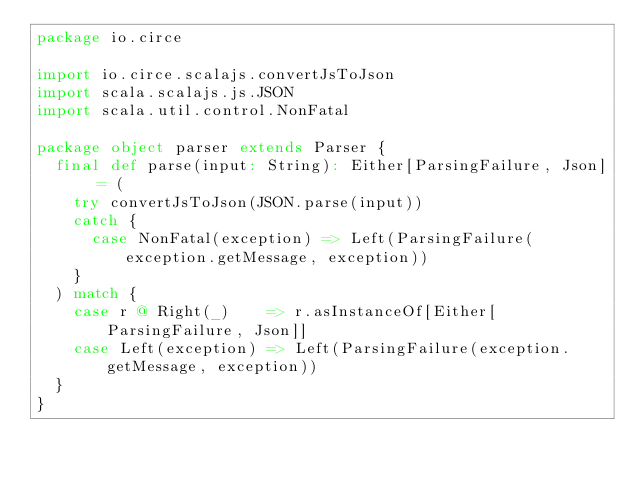<code> <loc_0><loc_0><loc_500><loc_500><_Scala_>package io.circe

import io.circe.scalajs.convertJsToJson
import scala.scalajs.js.JSON
import scala.util.control.NonFatal

package object parser extends Parser {
  final def parse(input: String): Either[ParsingFailure, Json] = (
    try convertJsToJson(JSON.parse(input))
    catch {
      case NonFatal(exception) => Left(ParsingFailure(exception.getMessage, exception))
    }
  ) match {
    case r @ Right(_)    => r.asInstanceOf[Either[ParsingFailure, Json]]
    case Left(exception) => Left(ParsingFailure(exception.getMessage, exception))
  }
}
</code> 